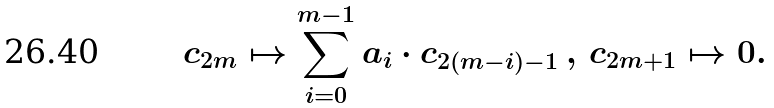<formula> <loc_0><loc_0><loc_500><loc_500>c _ { 2 m } \mapsto \sum _ { i = 0 } ^ { m - 1 } a _ { i } \cdot c _ { 2 ( m - i ) - 1 } \, , \, c _ { 2 m + 1 } \mapsto 0 .</formula> 